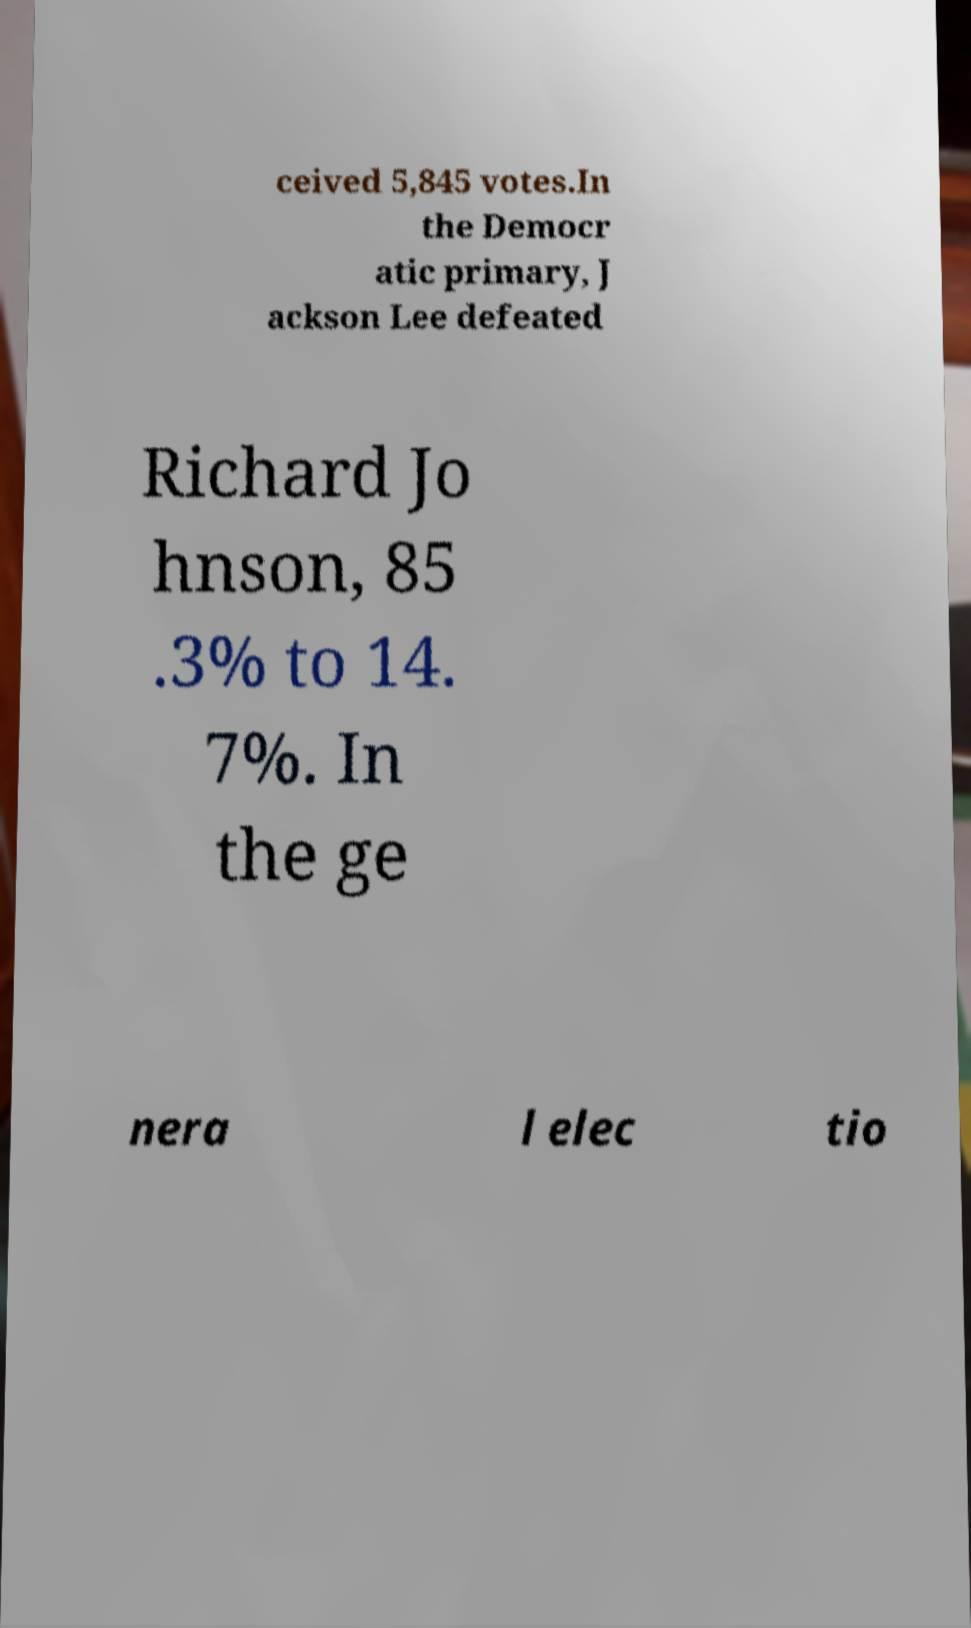There's text embedded in this image that I need extracted. Can you transcribe it verbatim? ceived 5,845 votes.In the Democr atic primary, J ackson Lee defeated Richard Jo hnson, 85 .3% to 14. 7%. In the ge nera l elec tio 